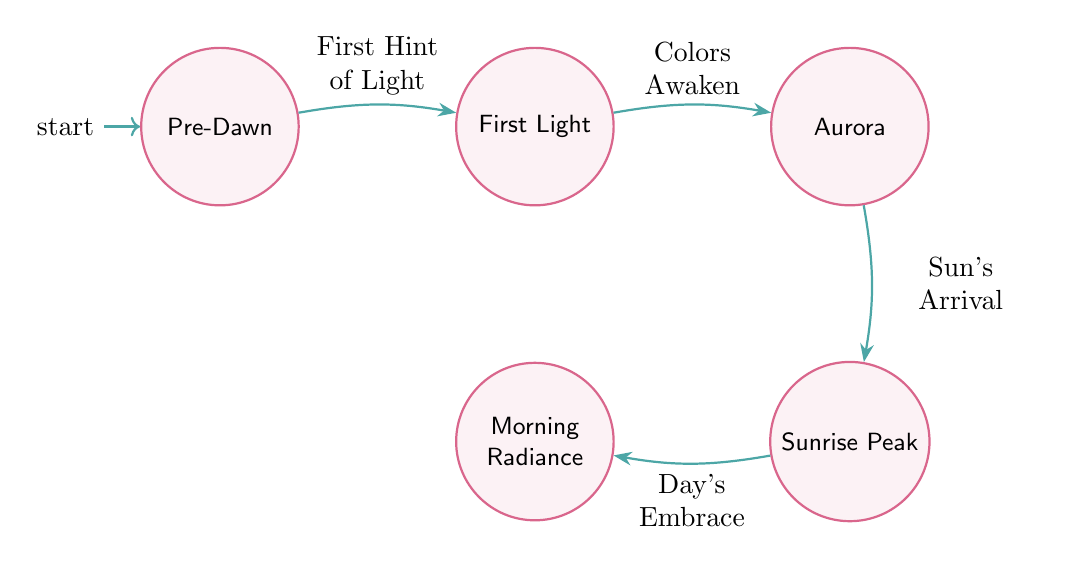What is the initial state in the diagram? The initial state is indicated by a special marker (an arrow) at the node "Pre-Dawn," which signifies where the process begins.
Answer: Pre-Dawn How many states are present in this finite state machine? By counting the nodes depicted in the diagram, there are five distinct states: Pre-Dawn, First Light, Aurora, Sunrise Peak, and Morning Radiance.
Answer: 5 What is the transition from "First Light" to "Aurora" called? The transition name can be found written on the arrow connecting the two states, which reads "Colors Awaken."
Answer: Colors Awaken Which state follows "Aurora"? Observing the flow of the diagram, the state that comes after "Aurora" is connected by an arrow leading to the state "Sunrise Peak."
Answer: Sunrise Peak What is the relationship between "Sunrise Peak" and "Morning Radiance"? The relationship is shown through a directed transition (arrow) leading from "Sunrise Peak" to "Morning Radiance," indicating a progression in the state.
Answer: Day's Embrace What color is used to represent the states in the diagram? The color filling the states is indicated in the style settings of the nodes within the diagram elements, which is a faint shade of purple.
Answer: Purple What describes the state "Aurora"? Looking at the description provided for the state, it describes the beautiful scene as "A palette of colors unfurls; pinks and purples merge into an ethereal dance."
Answer: A palette of colors unfurls; pinks and purples merge into an ethereal dance What is the last state in the finite state machine? The last state can be identified as the final node without any outgoing edges, which is "Morning Radiance."
Answer: Morning Radiance 